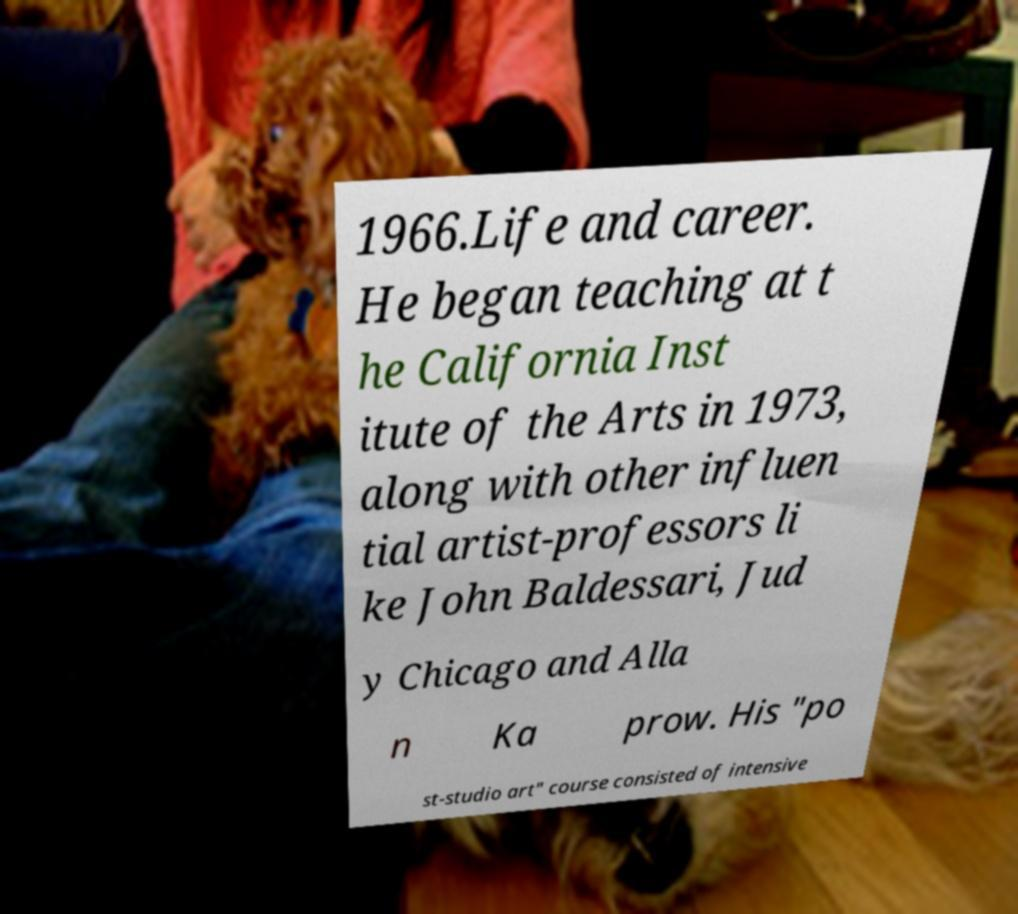Can you accurately transcribe the text from the provided image for me? 1966.Life and career. He began teaching at t he California Inst itute of the Arts in 1973, along with other influen tial artist-professors li ke John Baldessari, Jud y Chicago and Alla n Ka prow. His "po st-studio art" course consisted of intensive 